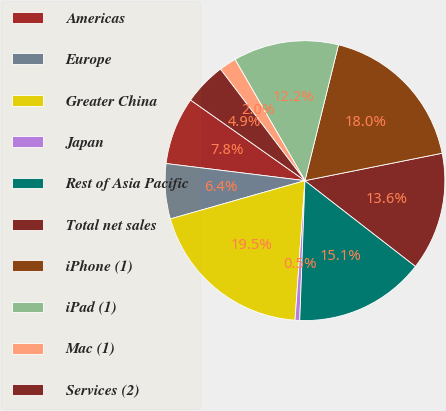Convert chart. <chart><loc_0><loc_0><loc_500><loc_500><pie_chart><fcel>Americas<fcel>Europe<fcel>Greater China<fcel>Japan<fcel>Rest of Asia Pacific<fcel>Total net sales<fcel>iPhone (1)<fcel>iPad (1)<fcel>Mac (1)<fcel>Services (2)<nl><fcel>7.82%<fcel>6.36%<fcel>19.46%<fcel>0.54%<fcel>15.09%<fcel>13.64%<fcel>18.01%<fcel>12.18%<fcel>1.99%<fcel>4.91%<nl></chart> 